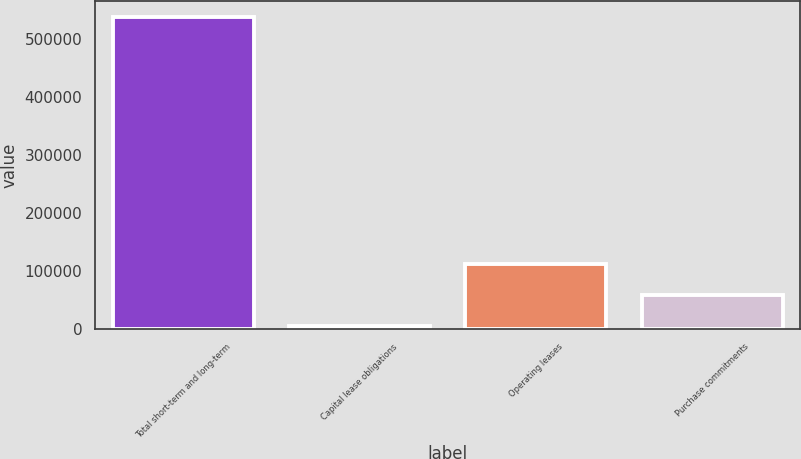Convert chart to OTSL. <chart><loc_0><loc_0><loc_500><loc_500><bar_chart><fcel>Total short-term and long-term<fcel>Capital lease obligations<fcel>Operating leases<fcel>Purchase commitments<nl><fcel>539000<fcel>4404<fcel>111323<fcel>57863.6<nl></chart> 